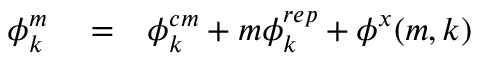<formula> <loc_0><loc_0><loc_500><loc_500>\begin{array} { r l r } { \phi _ { k } ^ { m } } & = } & { \phi _ { k } ^ { c m } + m \phi _ { k } ^ { r e p } + \phi ^ { x } ( m , k ) } \end{array}</formula> 